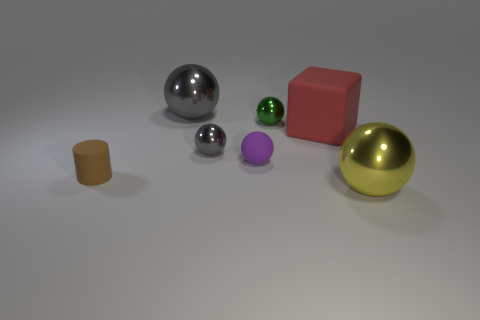There is a small purple thing that is the same shape as the yellow metal thing; what is its material? The small purple object, which shares its spherical shape with the larger yellow object, appears to be made of a matte material, suggesting it could be plastic or a painted surface, unlike the yellow object's reflective metallic finish. 